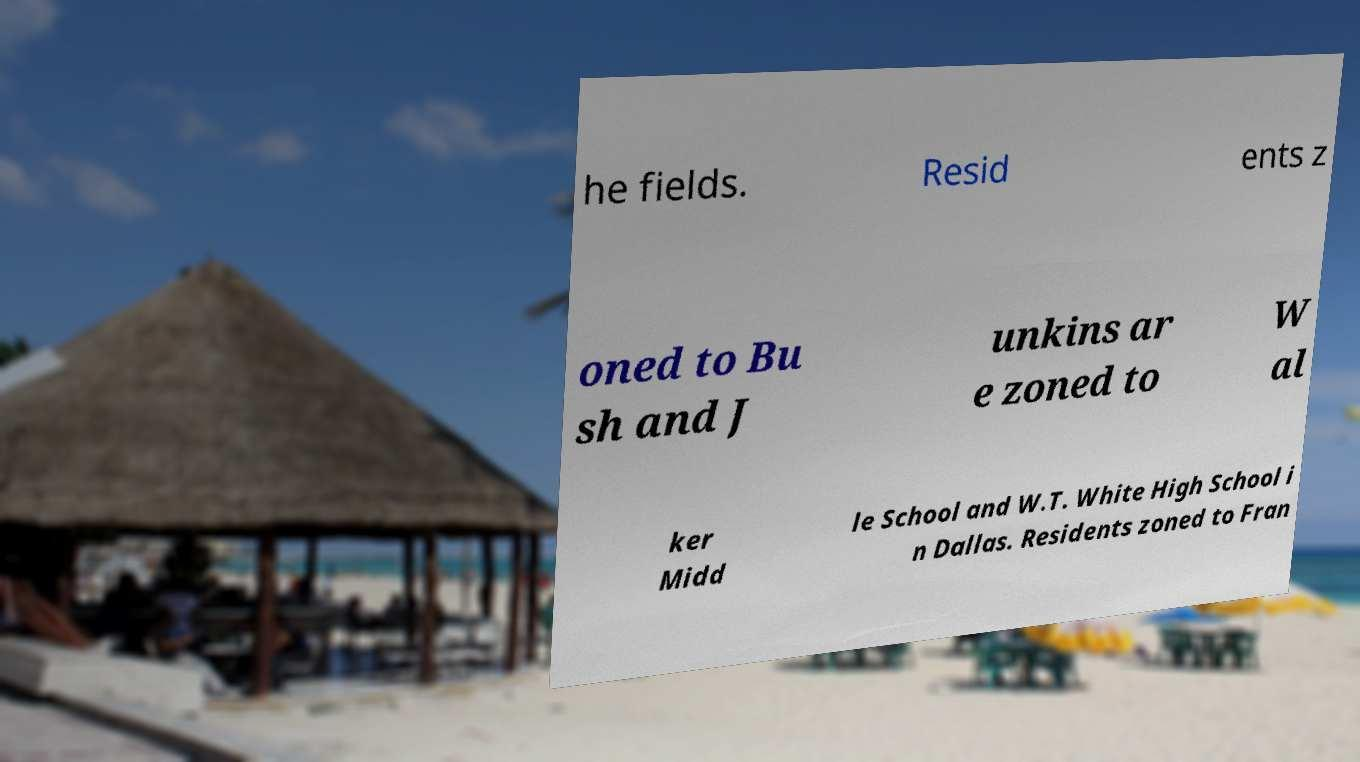There's text embedded in this image that I need extracted. Can you transcribe it verbatim? he fields. Resid ents z oned to Bu sh and J unkins ar e zoned to W al ker Midd le School and W.T. White High School i n Dallas. Residents zoned to Fran 